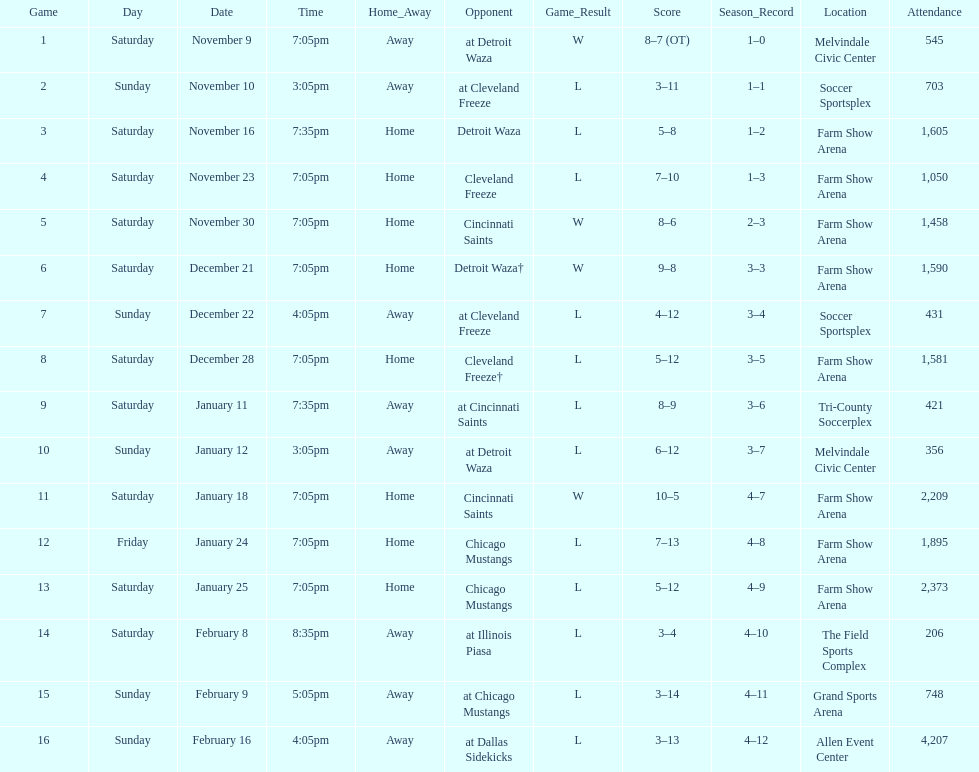How many games did the harrisburg heat lose to the cleveland freeze in total. 4. Could you parse the entire table as a dict? {'header': ['Game', 'Day', 'Date', 'Time', 'Home_Away', 'Opponent', 'Game_Result', 'Score', 'Season_Record', 'Location', 'Attendance'], 'rows': [['1', 'Saturday', 'November 9', '7:05pm', 'Away', 'at Detroit Waza', 'W', '8–7 (OT)', '1–0', 'Melvindale Civic Center', '545'], ['2', 'Sunday', 'November 10', '3:05pm', 'Away', 'at Cleveland Freeze', 'L', '3–11', '1–1', 'Soccer Sportsplex', '703'], ['3', 'Saturday', 'November 16', '7:35pm', 'Home', 'Detroit Waza', 'L', '5–8', '1–2', 'Farm Show Arena', '1,605'], ['4', 'Saturday', 'November 23', '7:05pm', 'Home', 'Cleveland Freeze', 'L', '7–10', '1–3', 'Farm Show Arena', '1,050'], ['5', 'Saturday', 'November 30', '7:05pm', 'Home', 'Cincinnati Saints', 'W', '8–6', '2–3', 'Farm Show Arena', '1,458'], ['6', 'Saturday', 'December 21', '7:05pm', 'Home', 'Detroit Waza†', 'W', '9–8', '3–3', 'Farm Show Arena', '1,590'], ['7', 'Sunday', 'December 22', '4:05pm', 'Away', 'at Cleveland Freeze', 'L', '4–12', '3–4', 'Soccer Sportsplex', '431'], ['8', 'Saturday', 'December 28', '7:05pm', 'Home', 'Cleveland Freeze†', 'L', '5–12', '3–5', 'Farm Show Arena', '1,581'], ['9', 'Saturday', 'January 11', '7:35pm', 'Away', 'at Cincinnati Saints', 'L', '8–9', '3–6', 'Tri-County Soccerplex', '421'], ['10', 'Sunday', 'January 12', '3:05pm', 'Away', 'at Detroit Waza', 'L', '6–12', '3–7', 'Melvindale Civic Center', '356'], ['11', 'Saturday', 'January 18', '7:05pm', 'Home', 'Cincinnati Saints', 'W', '10–5', '4–7', 'Farm Show Arena', '2,209'], ['12', 'Friday', 'January 24', '7:05pm', 'Home', 'Chicago Mustangs', 'L', '7–13', '4–8', 'Farm Show Arena', '1,895'], ['13', 'Saturday', 'January 25', '7:05pm', 'Home', 'Chicago Mustangs', 'L', '5–12', '4–9', 'Farm Show Arena', '2,373'], ['14', 'Saturday', 'February 8', '8:35pm', 'Away', 'at Illinois Piasa', 'L', '3–4', '4–10', 'The Field Sports Complex', '206'], ['15', 'Sunday', 'February 9', '5:05pm', 'Away', 'at Chicago Mustangs', 'L', '3–14', '4–11', 'Grand Sports Arena', '748'], ['16', 'Sunday', 'February 16', '4:05pm', 'Away', 'at Dallas Sidekicks', 'L', '3–13', '4–12', 'Allen Event Center', '4,207']]} 